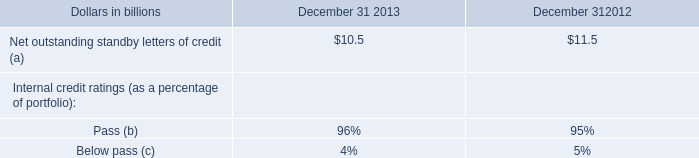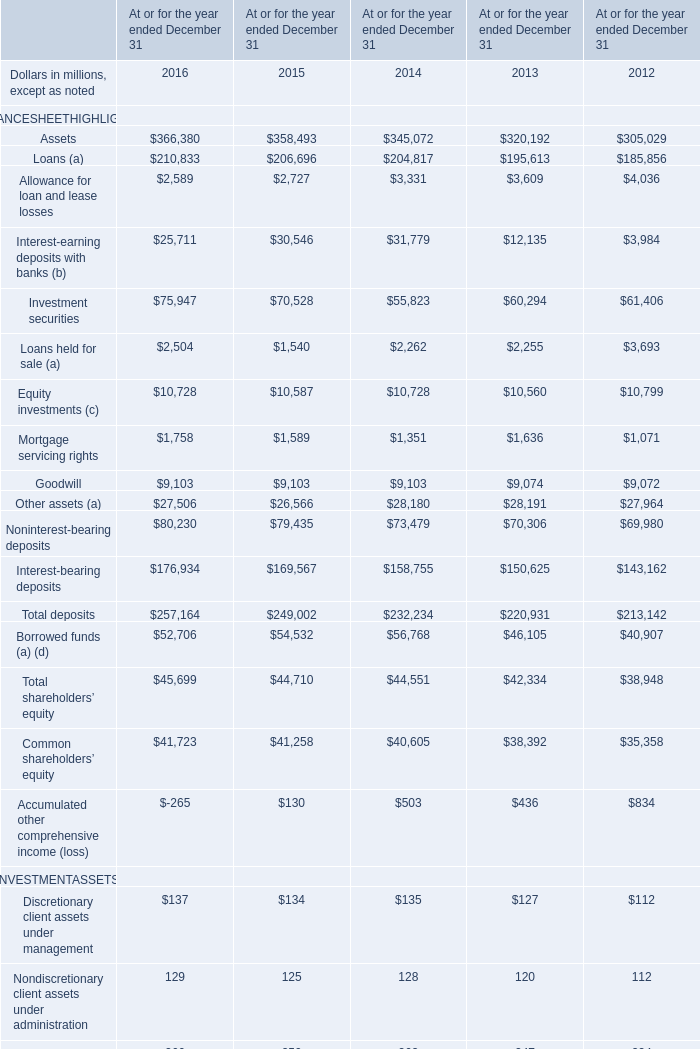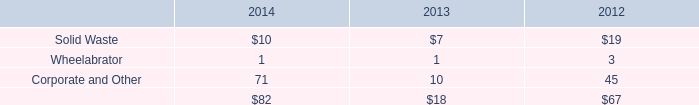What's the current increasing rate of the value of Investment securities on December 31? 
Computations: ((75947 - 70528) / 70528)
Answer: 0.07683. 